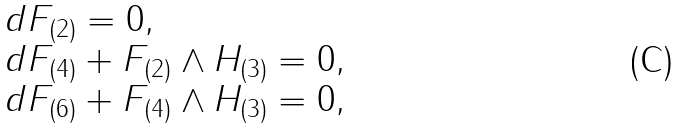Convert formula to latex. <formula><loc_0><loc_0><loc_500><loc_500>\begin{array} { l l l } & & d F _ { ( 2 ) } = 0 , \\ & & d F _ { ( 4 ) } + F _ { ( 2 ) } \wedge H _ { ( 3 ) } = 0 , \\ & & d F _ { ( 6 ) } + F _ { ( 4 ) } \wedge H _ { ( 3 ) } = 0 , \end{array}</formula> 